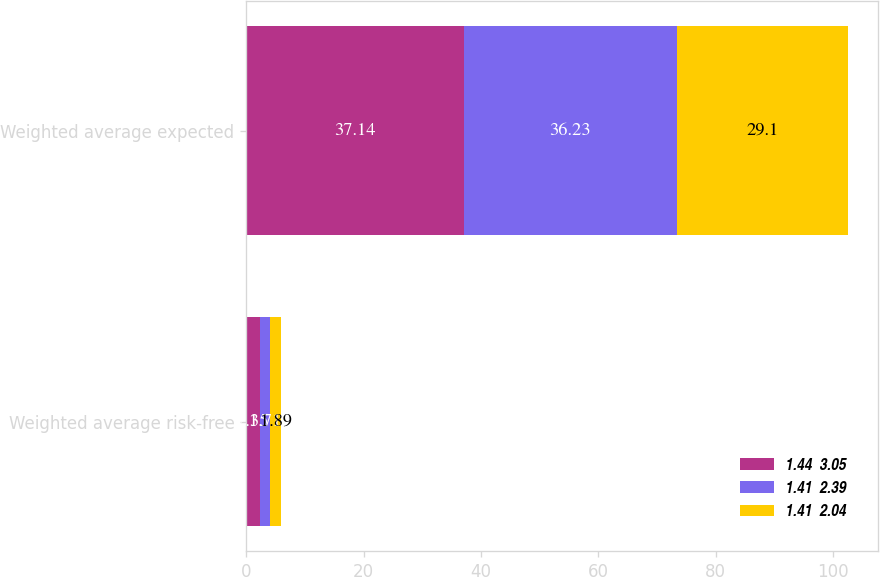Convert chart to OTSL. <chart><loc_0><loc_0><loc_500><loc_500><stacked_bar_chart><ecel><fcel>Weighted average risk-free<fcel>Weighted average expected<nl><fcel>1.44  3.05<fcel>2.35<fcel>37.14<nl><fcel>1.41  2.39<fcel>1.71<fcel>36.23<nl><fcel>1.41  2.04<fcel>1.89<fcel>29.1<nl></chart> 